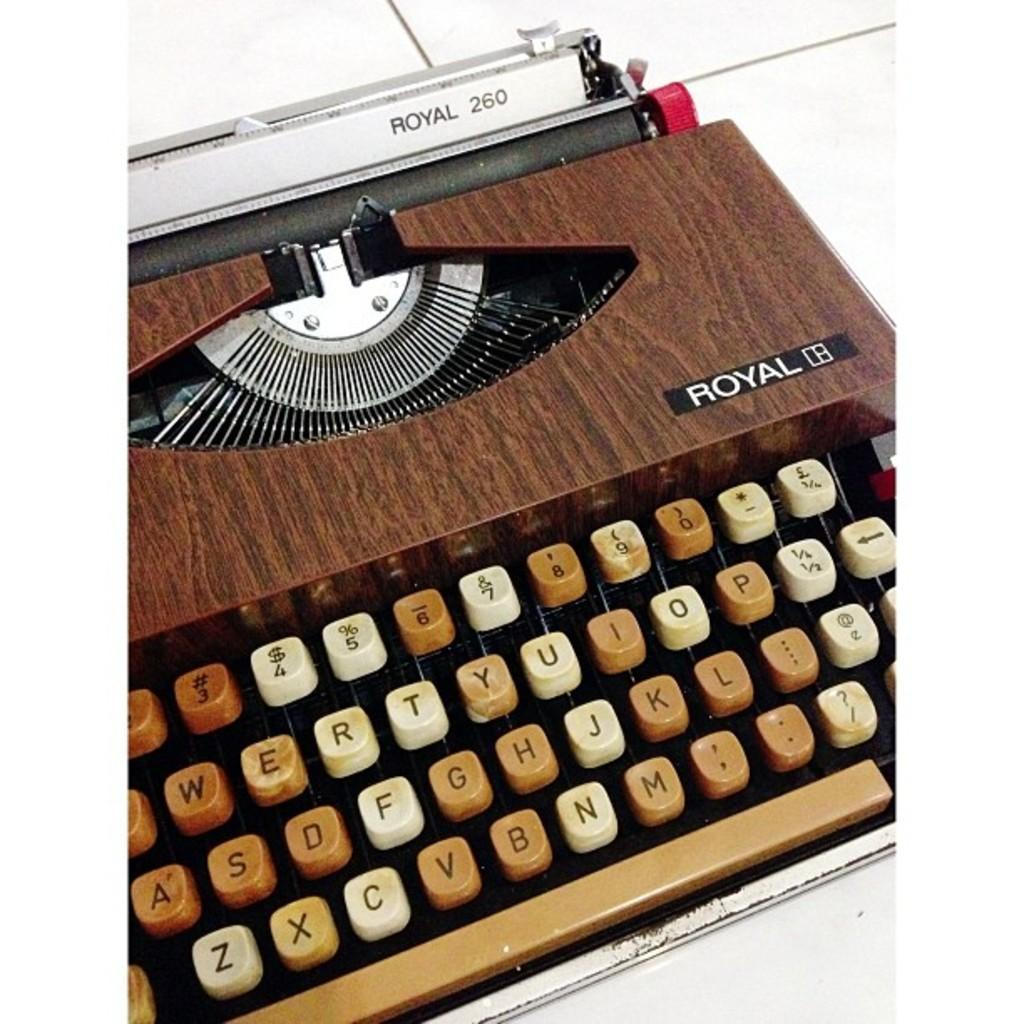<image>
Write a terse but informative summary of the picture. A type writer made by Royal that is made to look like wood. 